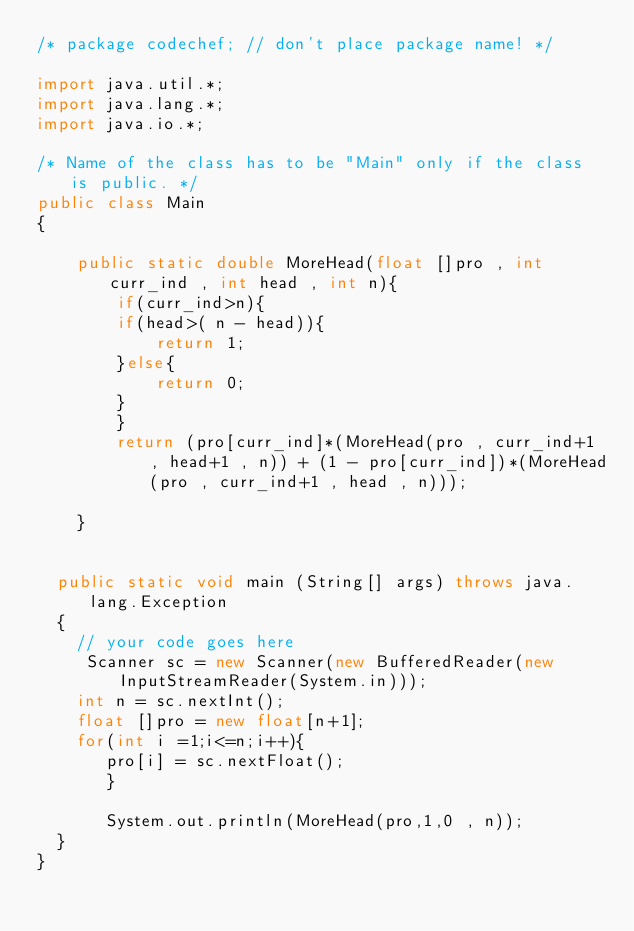<code> <loc_0><loc_0><loc_500><loc_500><_Java_>/* package codechef; // don't place package name! */

import java.util.*;
import java.lang.*;
import java.io.*;

/* Name of the class has to be "Main" only if the class is public. */
public class Main
{
    
    public static double MoreHead(float []pro , int curr_ind , int head , int n){
        if(curr_ind>n){
        if(head>( n - head)){
            return 1;
        }else{
            return 0;
        }
        }
        return (pro[curr_ind]*(MoreHead(pro , curr_ind+1 , head+1 , n)) + (1 - pro[curr_ind])*(MoreHead(pro , curr_ind+1 , head , n)));
        
    }
    
    
	public static void main (String[] args) throws java.lang.Exception
	{
		// your code goes here
		 Scanner sc = new Scanner(new BufferedReader(new InputStreamReader(System.in)));
		int n = sc.nextInt();
		float []pro = new float[n+1];
		for(int i =1;i<=n;i++){
		   pro[i] = sc.nextFloat(); 
		   }
		   
		   System.out.println(MoreHead(pro,1,0 , n));
	}
}
</code> 